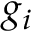<formula> <loc_0><loc_0><loc_500><loc_500>g _ { i }</formula> 